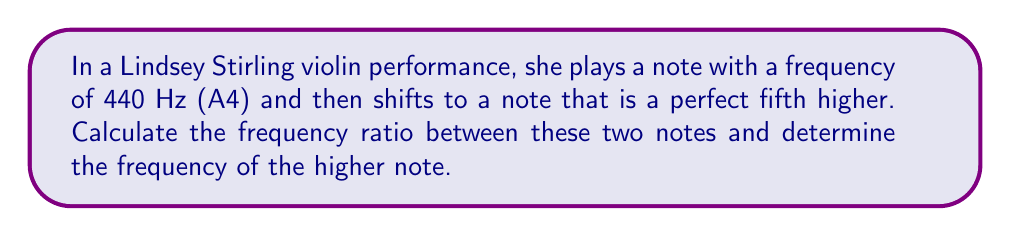Give your solution to this math problem. To solve this problem, we need to understand the relationship between musical notes and their frequencies. In Western music, a perfect fifth is an interval that spans seven semitones.

1) The frequency ratio for a perfect fifth is 3:2. This means that for every 2 cycles of the lower note, the higher note completes 3 cycles.

2) We can express this ratio mathematically as:

   $$\frac{f_2}{f_1} = \frac{3}{2}$$

   Where $f_1$ is the frequency of the lower note and $f_2$ is the frequency of the higher note.

3) We are given that $f_1 = 440$ Hz (A4). To find $f_2$, we can rearrange the equation:

   $$f_2 = f_1 \cdot \frac{3}{2}$$

4) Substituting the known value:

   $$f_2 = 440 \cdot \frac{3}{2} = 660$$

Therefore, the frequency of the higher note is 660 Hz, which corresponds to the note E5 in standard tuning.

The frequency ratio between these two notes is 3:2 or 1.5:1.
Answer: The frequency ratio between the two notes is 3:2 (or 1.5:1), and the frequency of the higher note is 660 Hz. 